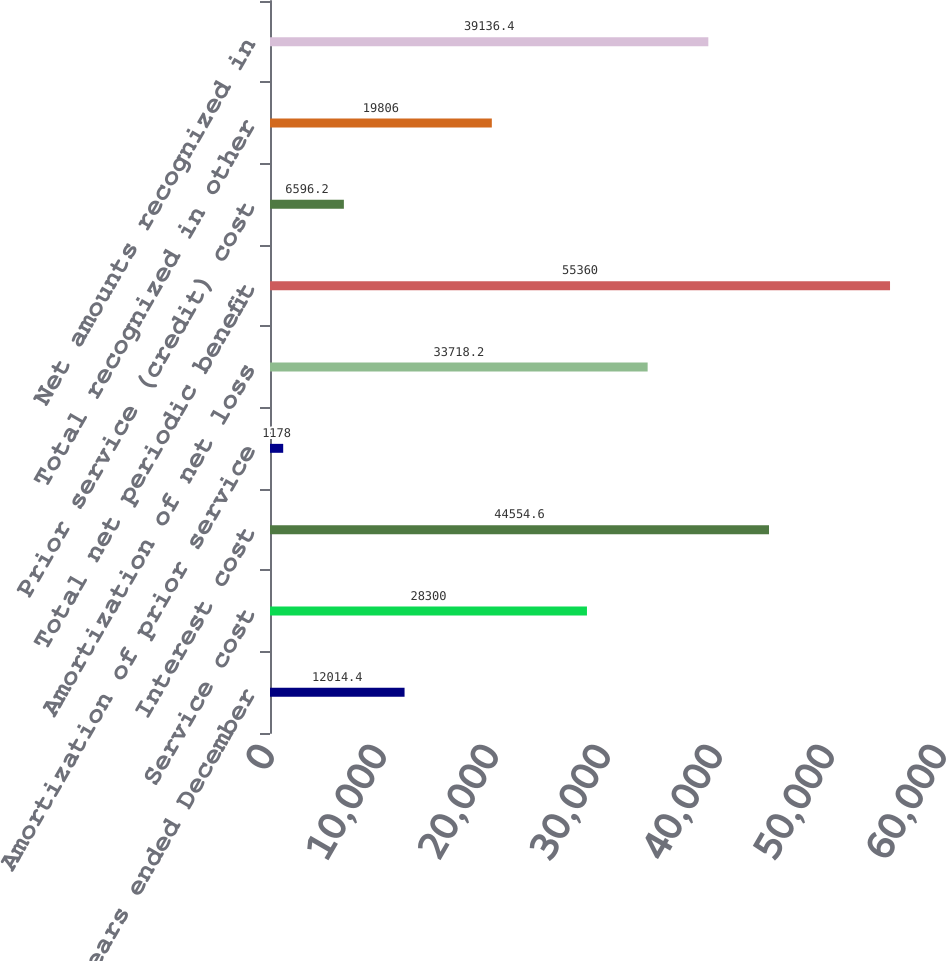Convert chart to OTSL. <chart><loc_0><loc_0><loc_500><loc_500><bar_chart><fcel>For the years ended December<fcel>Service cost<fcel>Interest cost<fcel>Amortization of prior service<fcel>Amortization of net loss<fcel>Total net periodic benefit<fcel>Prior service (credit) cost<fcel>Total recognized in other<fcel>Net amounts recognized in<nl><fcel>12014.4<fcel>28300<fcel>44554.6<fcel>1178<fcel>33718.2<fcel>55360<fcel>6596.2<fcel>19806<fcel>39136.4<nl></chart> 